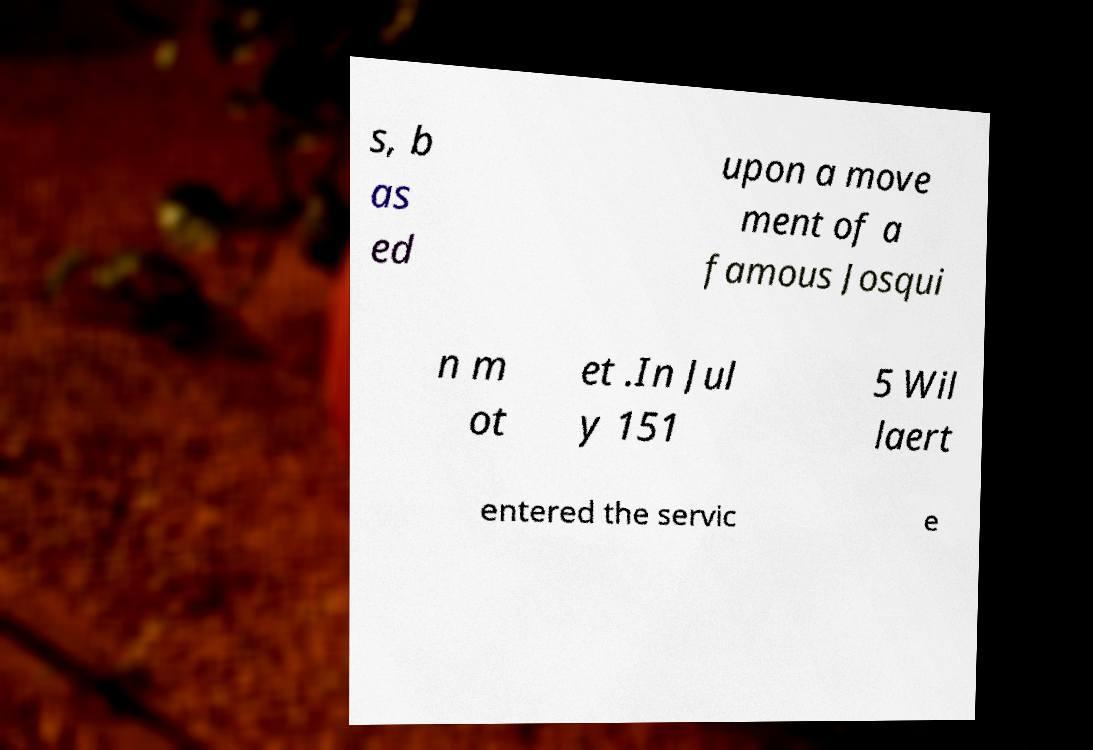There's text embedded in this image that I need extracted. Can you transcribe it verbatim? s, b as ed upon a move ment of a famous Josqui n m ot et .In Jul y 151 5 Wil laert entered the servic e 